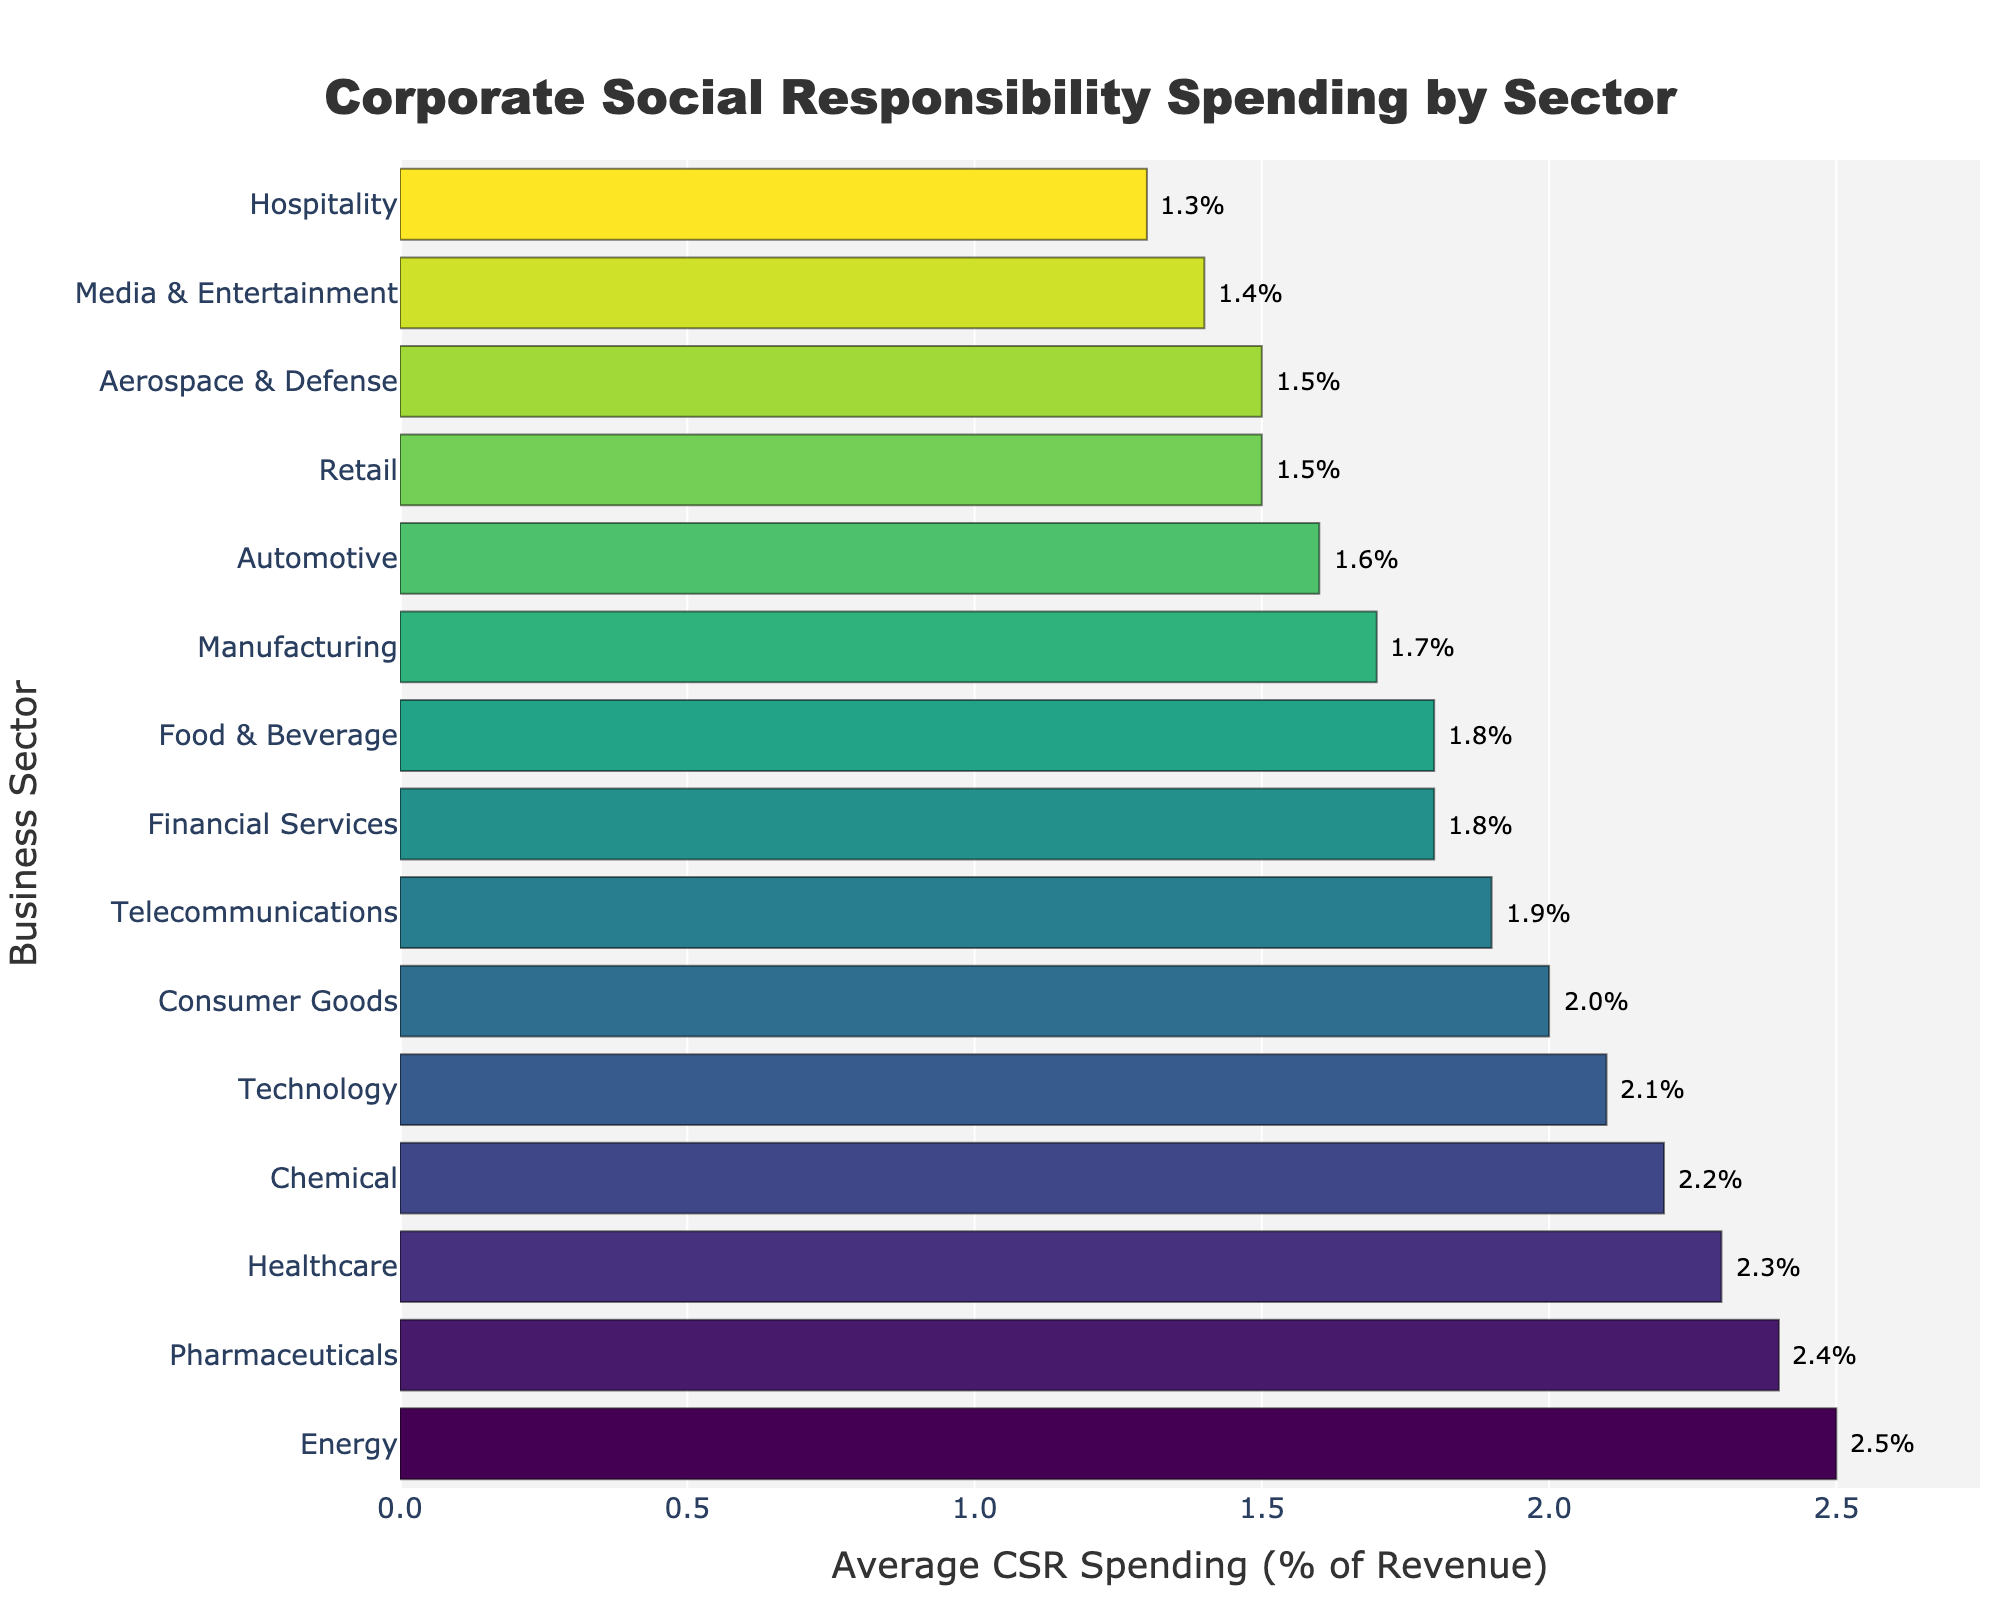What's the sector with the highest CSR spending? The bar chart shows the spending percentages for each sector. The sector with the highest bar corresponds to the highest CSR spending. In this case, it is the Energy sector with 2.5%.
Answer: Energy Which sector has the lowest CSR spending? The shortest bar in the bar chart represents the sector with the lowest CSR spending. Here, it is the Hospitality sector with 1.3%.
Answer: Hospitality What is the average CSR spending across all sectors? To find the average CSR spending, sum all individual percentages and divide by the number of sectors. The calculation is (2.1 + 1.8 + 2.3 + 1.5 + 1.7 + 2.5 + 1.9 + 2.0 + 1.6 + 2.4 + 1.4 + 1.8 + 1.5 + 1.3 + 2.2) / 15 = 29.0 / 15 = 1.93.
Answer: 1.93 Which two sectors have the closest CSR spending percentages? By examining the lengths of the bars, we see the Technology sector (2.1%) and Consumer Goods sector (2.0%) have the closest values with only a 0.1% difference.
Answer: Technology and Consumer Goods What is the total CSR spending percentage for the Technology, Healthcare, and Financial Services sectors? Sum the CSR spending percentages for these sectors: 2.1 (Technology) + 2.3 (Healthcare) + 1.8 (Financial Services) = 6.2.
Answer: 6.2 Is the average CSR spending in the Healthcare sector greater than that in the Automotive sector? The CSR spending for Healthcare is 2.3% and for Automotive is 1.6%. Comparing these values shows that Healthcare (2.3%) is greater than Automotive (1.6%).
Answer: Yes What is the difference in CSR spending between the Energy and Chemical sectors? Subtract the CSR spending of the Chemical sector from that of the Energy sector: 2.5 (Energy) - 2.2 (Chemical) = 0.3.
Answer: 0.3 How many sectors have CSR spending greater than 2%? Count the bars whose values exceed 2%. The sectors are Technology (2.1%), Healthcare (2.3%), Energy (2.5%), Pharmaceuticals (2.4%), and Chemical (2.2%). There are 5 such sectors.
Answer: 5 Which sector spends more on CSR, Pharmaceuticals or Media & Entertainment? By comparing the bar lengths, Pharmaceuticals spends 2.4% while Media & Entertainment spends 1.4%. Pharmaceuticals spends more on CSR.
Answer: Pharmaceuticals 